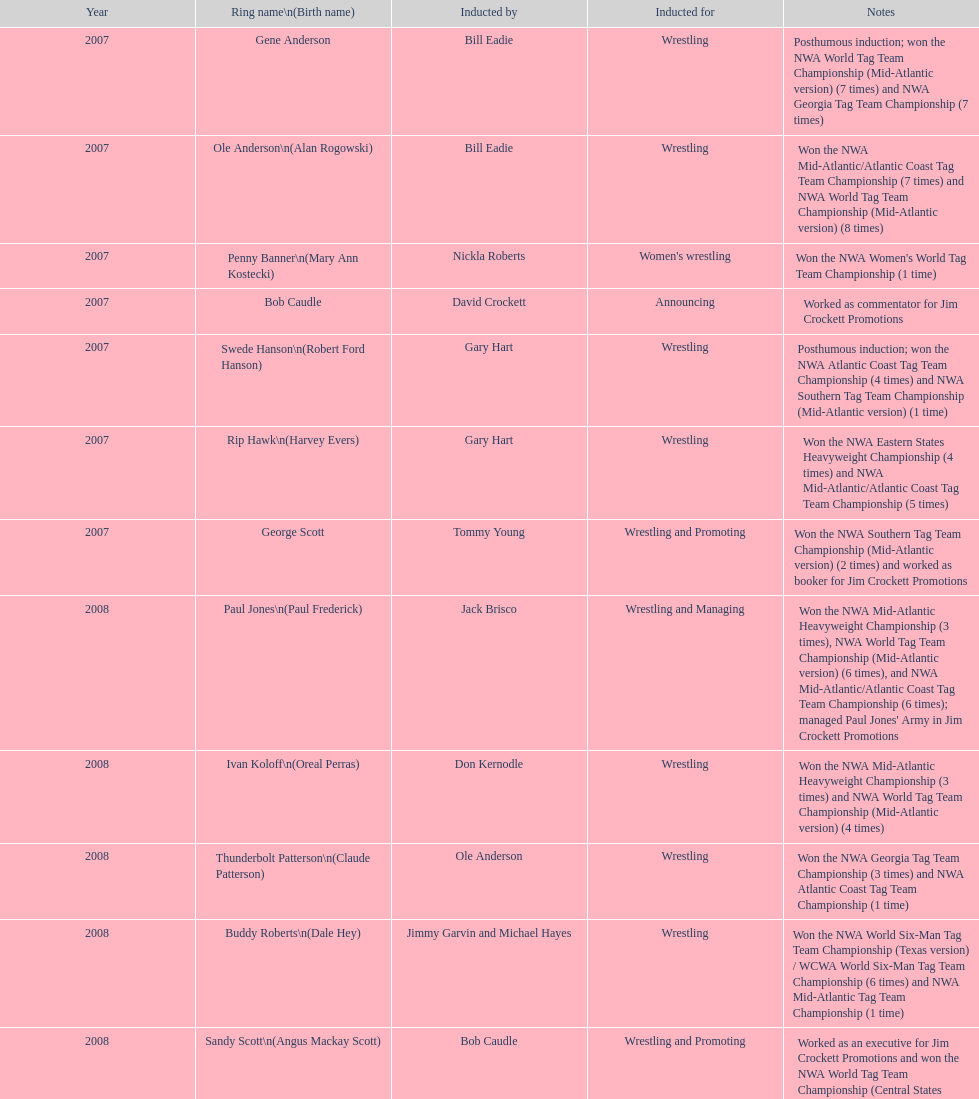Bob caudle was a commentator, who was the other one? Lance Russell. Would you be able to parse every entry in this table? {'header': ['Year', 'Ring name\\n(Birth name)', 'Inducted by', 'Inducted for', 'Notes'], 'rows': [['2007', 'Gene Anderson', 'Bill Eadie', 'Wrestling', 'Posthumous induction; won the NWA World Tag Team Championship (Mid-Atlantic version) (7 times) and NWA Georgia Tag Team Championship (7 times)'], ['2007', 'Ole Anderson\\n(Alan Rogowski)', 'Bill Eadie', 'Wrestling', 'Won the NWA Mid-Atlantic/Atlantic Coast Tag Team Championship (7 times) and NWA World Tag Team Championship (Mid-Atlantic version) (8 times)'], ['2007', 'Penny Banner\\n(Mary Ann Kostecki)', 'Nickla Roberts', "Women's wrestling", "Won the NWA Women's World Tag Team Championship (1 time)"], ['2007', 'Bob Caudle', 'David Crockett', 'Announcing', 'Worked as commentator for Jim Crockett Promotions'], ['2007', 'Swede Hanson\\n(Robert Ford Hanson)', 'Gary Hart', 'Wrestling', 'Posthumous induction; won the NWA Atlantic Coast Tag Team Championship (4 times) and NWA Southern Tag Team Championship (Mid-Atlantic version) (1 time)'], ['2007', 'Rip Hawk\\n(Harvey Evers)', 'Gary Hart', 'Wrestling', 'Won the NWA Eastern States Heavyweight Championship (4 times) and NWA Mid-Atlantic/Atlantic Coast Tag Team Championship (5 times)'], ['2007', 'George Scott', 'Tommy Young', 'Wrestling and Promoting', 'Won the NWA Southern Tag Team Championship (Mid-Atlantic version) (2 times) and worked as booker for Jim Crockett Promotions'], ['2008', 'Paul Jones\\n(Paul Frederick)', 'Jack Brisco', 'Wrestling and Managing', "Won the NWA Mid-Atlantic Heavyweight Championship (3 times), NWA World Tag Team Championship (Mid-Atlantic version) (6 times), and NWA Mid-Atlantic/Atlantic Coast Tag Team Championship (6 times); managed Paul Jones' Army in Jim Crockett Promotions"], ['2008', 'Ivan Koloff\\n(Oreal Perras)', 'Don Kernodle', 'Wrestling', 'Won the NWA Mid-Atlantic Heavyweight Championship (3 times) and NWA World Tag Team Championship (Mid-Atlantic version) (4 times)'], ['2008', 'Thunderbolt Patterson\\n(Claude Patterson)', 'Ole Anderson', 'Wrestling', 'Won the NWA Georgia Tag Team Championship (3 times) and NWA Atlantic Coast Tag Team Championship (1 time)'], ['2008', 'Buddy Roberts\\n(Dale Hey)', 'Jimmy Garvin and Michael Hayes', 'Wrestling', 'Won the NWA World Six-Man Tag Team Championship (Texas version) / WCWA World Six-Man Tag Team Championship (6 times) and NWA Mid-Atlantic Tag Team Championship (1 time)'], ['2008', 'Sandy Scott\\n(Angus Mackay Scott)', 'Bob Caudle', 'Wrestling and Promoting', 'Worked as an executive for Jim Crockett Promotions and won the NWA World Tag Team Championship (Central States version) (1 time) and NWA Southern Tag Team Championship (Mid-Atlantic version) (3 times)'], ['2008', 'Grizzly Smith\\n(Aurelian Smith)', 'Magnum T.A.', 'Wrestling', 'Won the NWA United States Tag Team Championship (Tri-State version) (2 times) and NWA Texas Heavyweight Championship (1 time)'], ['2008', 'Johnny Weaver\\n(Kenneth Eugene Weaver)', 'Rip Hawk', 'Wrestling', 'Posthumous induction; won the NWA Atlantic Coast/Mid-Atlantic Tag Team Championship (8 times) and NWA Southern Tag Team Championship (Mid-Atlantic version) (6 times)'], ['2009', 'Don Fargo\\n(Don Kalt)', 'Jerry Jarrett & Steve Keirn', 'Wrestling', 'Won the NWA Southern Tag Team Championship (Mid-America version) (2 times) and NWA World Tag Team Championship (Mid-America version) (6 times)'], ['2009', 'Jackie Fargo\\n(Henry Faggart)', 'Jerry Jarrett & Steve Keirn', 'Wrestling', 'Won the NWA World Tag Team Championship (Mid-America version) (10 times) and NWA Southern Tag Team Championship (Mid-America version) (22 times)'], ['2009', 'Sonny Fargo\\n(Jack Lewis Faggart)', 'Jerry Jarrett & Steve Keirn', 'Wrestling', 'Posthumous induction; won the NWA Southern Tag Team Championship (Mid-America version) (3 times)'], ['2009', 'Gary Hart\\n(Gary Williams)', 'Sir Oliver Humperdink', 'Managing and Promoting', 'Posthumous induction; worked as a booker in World Class Championship Wrestling and managed several wrestlers in Mid-Atlantic Championship Wrestling'], ['2009', 'Wahoo McDaniel\\n(Edward McDaniel)', 'Tully Blanchard', 'Wrestling', 'Posthumous induction; won the NWA Mid-Atlantic Heavyweight Championship (6 times) and NWA World Tag Team Championship (Mid-Atlantic version) (4 times)'], ['2009', 'Blackjack Mulligan\\n(Robert Windham)', 'Ric Flair', 'Wrestling', 'Won the NWA Texas Heavyweight Championship (1 time) and NWA World Tag Team Championship (Mid-Atlantic version) (1 time)'], ['2009', 'Nelson Royal', 'Brad Anderson, Tommy Angel & David Isley', 'Wrestling', 'Won the NWA Atlantic Coast Tag Team Championship (2 times)'], ['2009', 'Lance Russell', 'Dave Brown', 'Announcing', 'Worked as commentator for wrestling events in the Memphis area']]} 